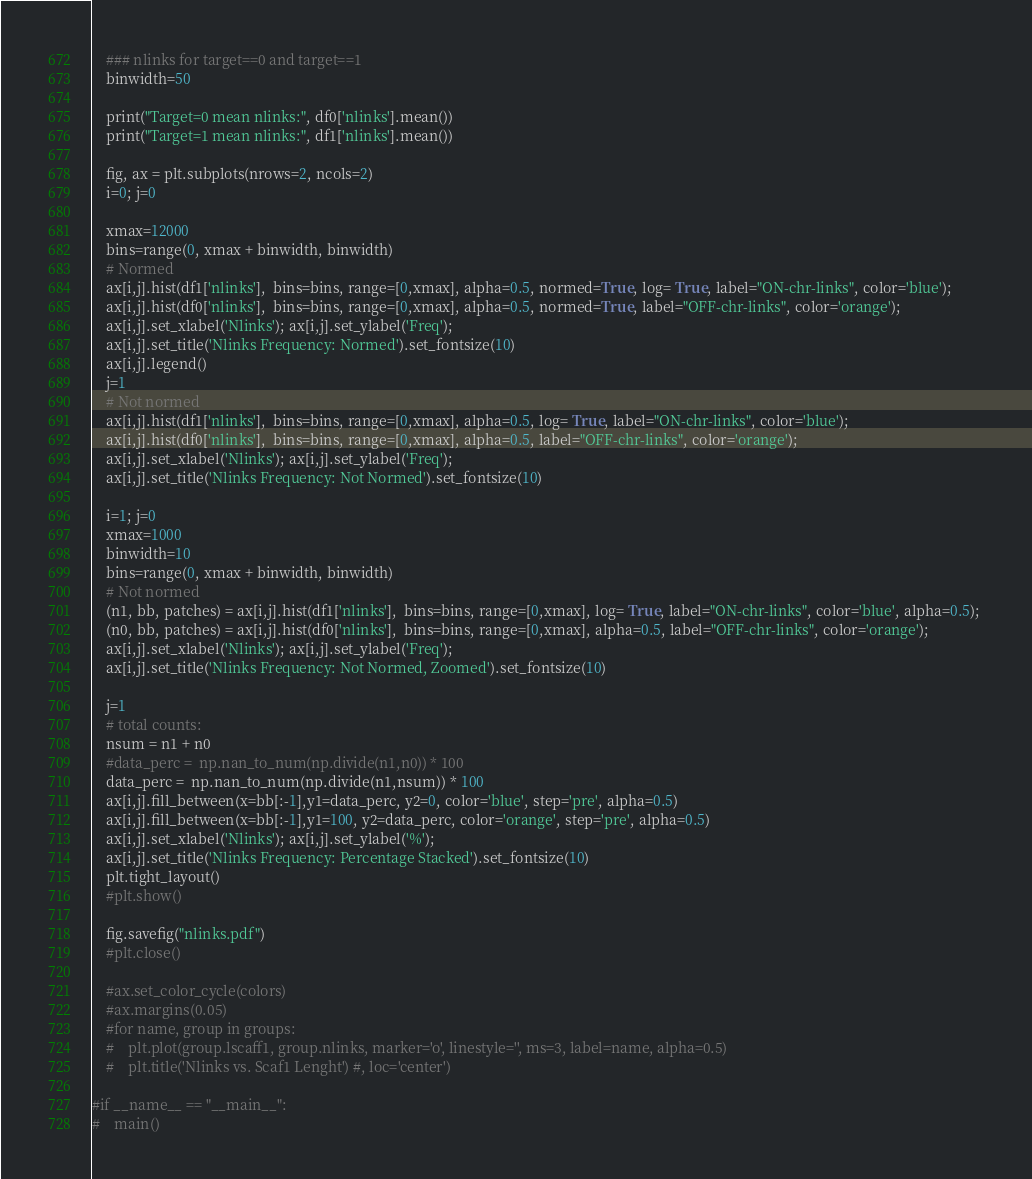<code> <loc_0><loc_0><loc_500><loc_500><_Python_>

    ### nlinks for target==0 and target==1 
    binwidth=50

    print("Target=0 mean nlinks:", df0['nlinks'].mean())
    print("Target=1 mean nlinks:", df1['nlinks'].mean())

    fig, ax = plt.subplots(nrows=2, ncols=2)
    i=0; j=0

    xmax=12000
    bins=range(0, xmax + binwidth, binwidth)
    # Normed
    ax[i,j].hist(df1['nlinks'],  bins=bins, range=[0,xmax], alpha=0.5, normed=True, log= True, label="ON-chr-links", color='blue');
    ax[i,j].hist(df0['nlinks'],  bins=bins, range=[0,xmax], alpha=0.5, normed=True, label="OFF-chr-links", color='orange');
    ax[i,j].set_xlabel('Nlinks'); ax[i,j].set_ylabel('Freq');
    ax[i,j].set_title('Nlinks Frequency: Normed').set_fontsize(10)
    ax[i,j].legend()
    j=1
    # Not normed
    ax[i,j].hist(df1['nlinks'],  bins=bins, range=[0,xmax], alpha=0.5, log= True, label="ON-chr-links", color='blue'); 
    ax[i,j].hist(df0['nlinks'],  bins=bins, range=[0,xmax], alpha=0.5, label="OFF-chr-links", color='orange');
    ax[i,j].set_xlabel('Nlinks'); ax[i,j].set_ylabel('Freq');
    ax[i,j].set_title('Nlinks Frequency: Not Normed').set_fontsize(10)

    i=1; j=0
    xmax=1000
    binwidth=10
    bins=range(0, xmax + binwidth, binwidth)
    # Not normed
    (n1, bb, patches) = ax[i,j].hist(df1['nlinks'],  bins=bins, range=[0,xmax], log= True, label="ON-chr-links", color='blue', alpha=0.5); 
    (n0, bb, patches) = ax[i,j].hist(df0['nlinks'],  bins=bins, range=[0,xmax], alpha=0.5, label="OFF-chr-links", color='orange');
    ax[i,j].set_xlabel('Nlinks'); ax[i,j].set_ylabel('Freq');
    ax[i,j].set_title('Nlinks Frequency: Not Normed, Zoomed').set_fontsize(10)

    j=1
    # total counts:
    nsum = n1 + n0
    #data_perc =  np.nan_to_num(np.divide(n1,n0)) * 100
    data_perc =  np.nan_to_num(np.divide(n1,nsum)) * 100
    ax[i,j].fill_between(x=bb[:-1],y1=data_perc, y2=0, color='blue', step='pre', alpha=0.5)
    ax[i,j].fill_between(x=bb[:-1],y1=100, y2=data_perc, color='orange', step='pre', alpha=0.5)
    ax[i,j].set_xlabel('Nlinks'); ax[i,j].set_ylabel('%');
    ax[i,j].set_title('Nlinks Frequency: Percentage Stacked').set_fontsize(10)
    plt.tight_layout()
    #plt.show()

    fig.savefig("nlinks.pdf")
    #plt.close()

    #ax.set_color_cycle(colors)
    #ax.margins(0.05)
    #for name, group in groups:
    #    plt.plot(group.lscaff1, group.nlinks, marker='o', linestyle='', ms=3, label=name, alpha=0.5) 
    #    plt.title('Nlinks vs. Scaf1 Lenght') #, loc='center')
 
#if __name__ == "__main__":
#    main()
</code> 